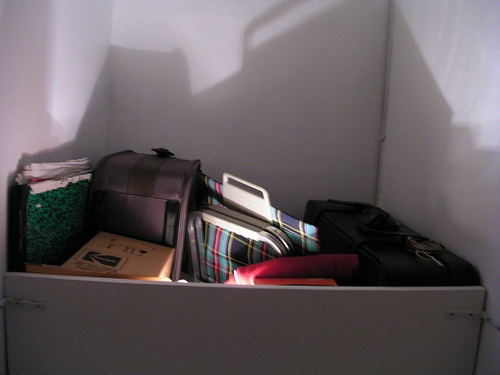Describe the objects in this image and their specific colors. I can see suitcase in gray and black tones and book in gray, black, darkgreen, and darkgray tones in this image. 